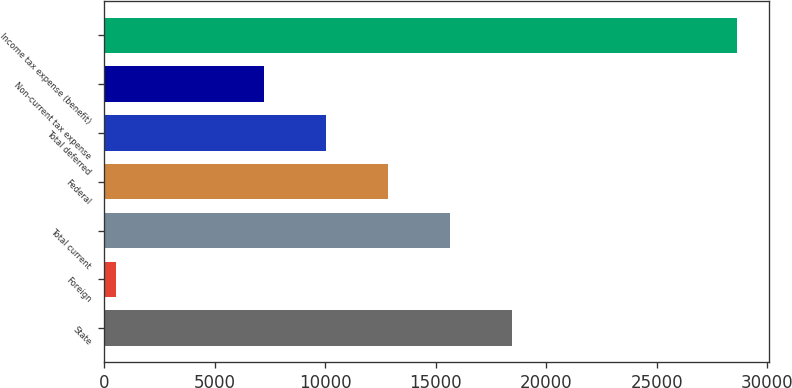Convert chart to OTSL. <chart><loc_0><loc_0><loc_500><loc_500><bar_chart><fcel>State<fcel>Foreign<fcel>Total current<fcel>Federal<fcel>Total deferred<fcel>Non-current tax expense<fcel>Income tax expense (benefit)<nl><fcel>18447.4<fcel>523<fcel>15636.8<fcel>12826.2<fcel>10015.6<fcel>7205<fcel>28629<nl></chart> 